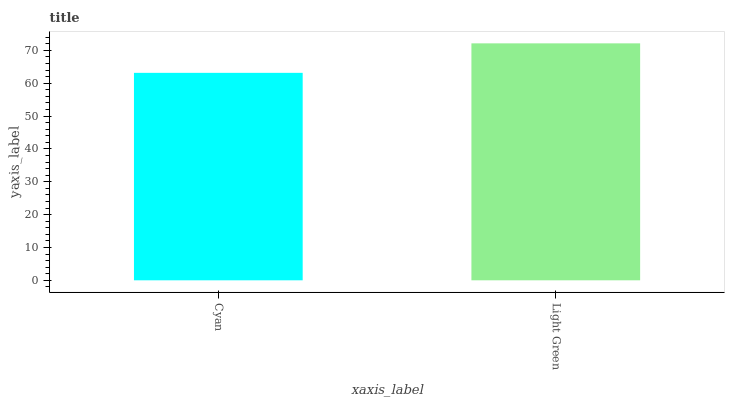Is Cyan the minimum?
Answer yes or no. Yes. Is Light Green the maximum?
Answer yes or no. Yes. Is Light Green the minimum?
Answer yes or no. No. Is Light Green greater than Cyan?
Answer yes or no. Yes. Is Cyan less than Light Green?
Answer yes or no. Yes. Is Cyan greater than Light Green?
Answer yes or no. No. Is Light Green less than Cyan?
Answer yes or no. No. Is Light Green the high median?
Answer yes or no. Yes. Is Cyan the low median?
Answer yes or no. Yes. Is Cyan the high median?
Answer yes or no. No. Is Light Green the low median?
Answer yes or no. No. 